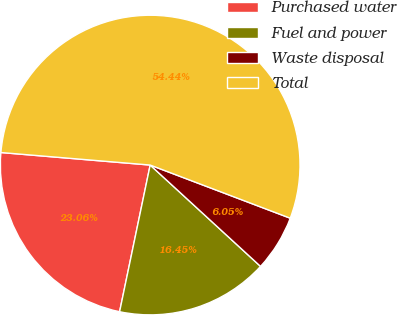<chart> <loc_0><loc_0><loc_500><loc_500><pie_chart><fcel>Purchased water<fcel>Fuel and power<fcel>Waste disposal<fcel>Total<nl><fcel>23.06%<fcel>16.45%<fcel>6.05%<fcel>54.44%<nl></chart> 